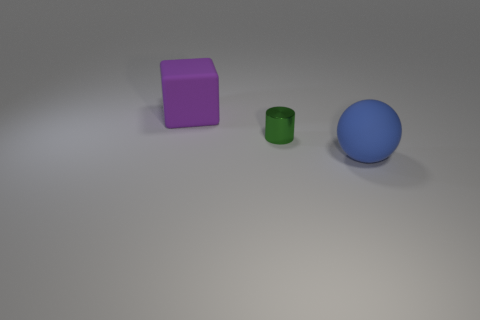Add 2 green cubes. How many objects exist? 5 Subtract all spheres. How many objects are left? 2 Add 3 big blue things. How many big blue things are left? 4 Add 1 small yellow metallic cubes. How many small yellow metallic cubes exist? 1 Subtract 0 brown cylinders. How many objects are left? 3 Subtract all cubes. Subtract all spheres. How many objects are left? 1 